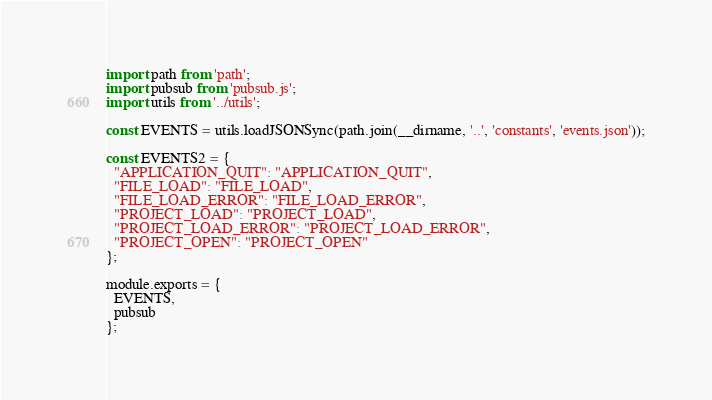Convert code to text. <code><loc_0><loc_0><loc_500><loc_500><_JavaScript_>import path from 'path';
import pubsub from 'pubsub.js';
import utils from '../utils';

const EVENTS = utils.loadJSONSync(path.join(__dirname, '..', 'constants', 'events.json'));

const EVENTS2 = {
  "APPLICATION_QUIT": "APPLICATION_QUIT",
  "FILE_LOAD": "FILE_LOAD",
  "FILE_LOAD_ERROR": "FILE_LOAD_ERROR",
  "PROJECT_LOAD": "PROJECT_LOAD",
  "PROJECT_LOAD_ERROR": "PROJECT_LOAD_ERROR",
  "PROJECT_OPEN": "PROJECT_OPEN"
};

module.exports = {
  EVENTS,
  pubsub
};
</code> 